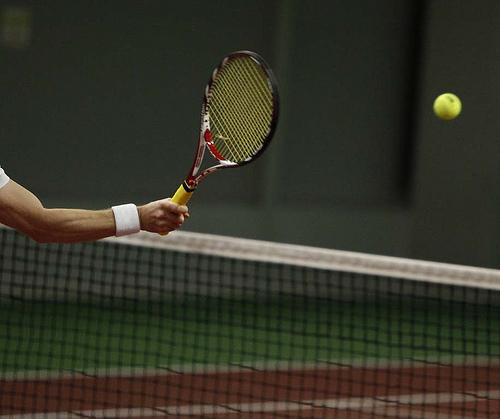Do you see a face?
Be succinct. No. What is the person going to do?
Give a very brief answer. Hit ball. What color is the round spot on the racquet?
Quick response, please. Yellow. Is the arm wearing a wristband?
Short answer required. Yes. What color is the ball?
Write a very short answer. Yellow. 